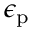<formula> <loc_0><loc_0><loc_500><loc_500>\epsilon _ { p }</formula> 